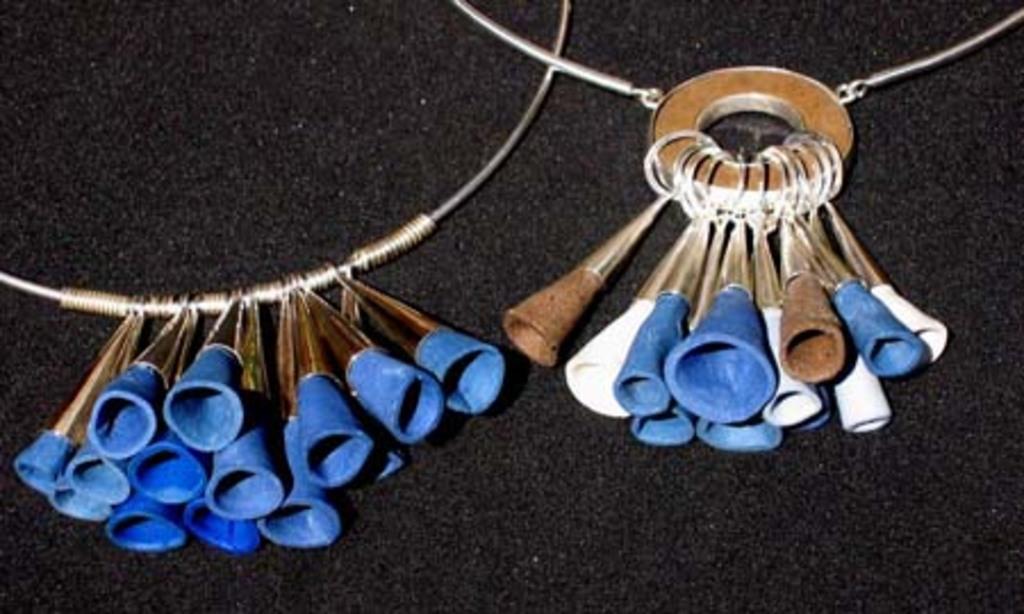Could you give a brief overview of what you see in this image? In this image there are ornaments which are on the black colour surface. 